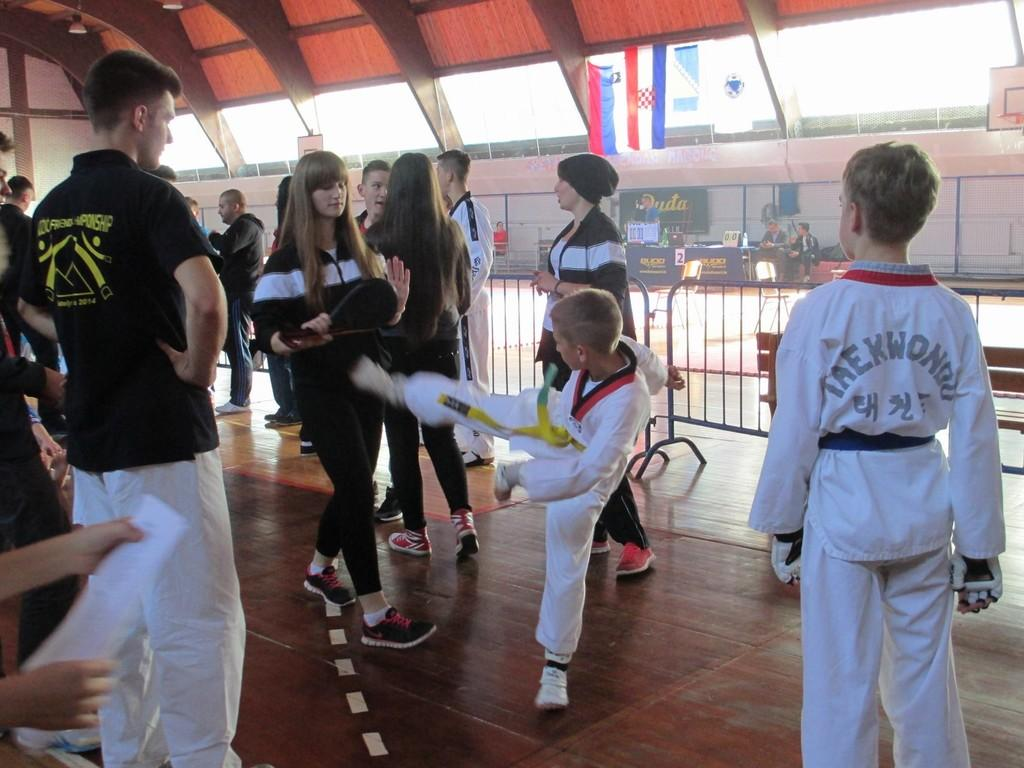<image>
Describe the image concisely. The kid in the white jersey has Taekwondo on the back 